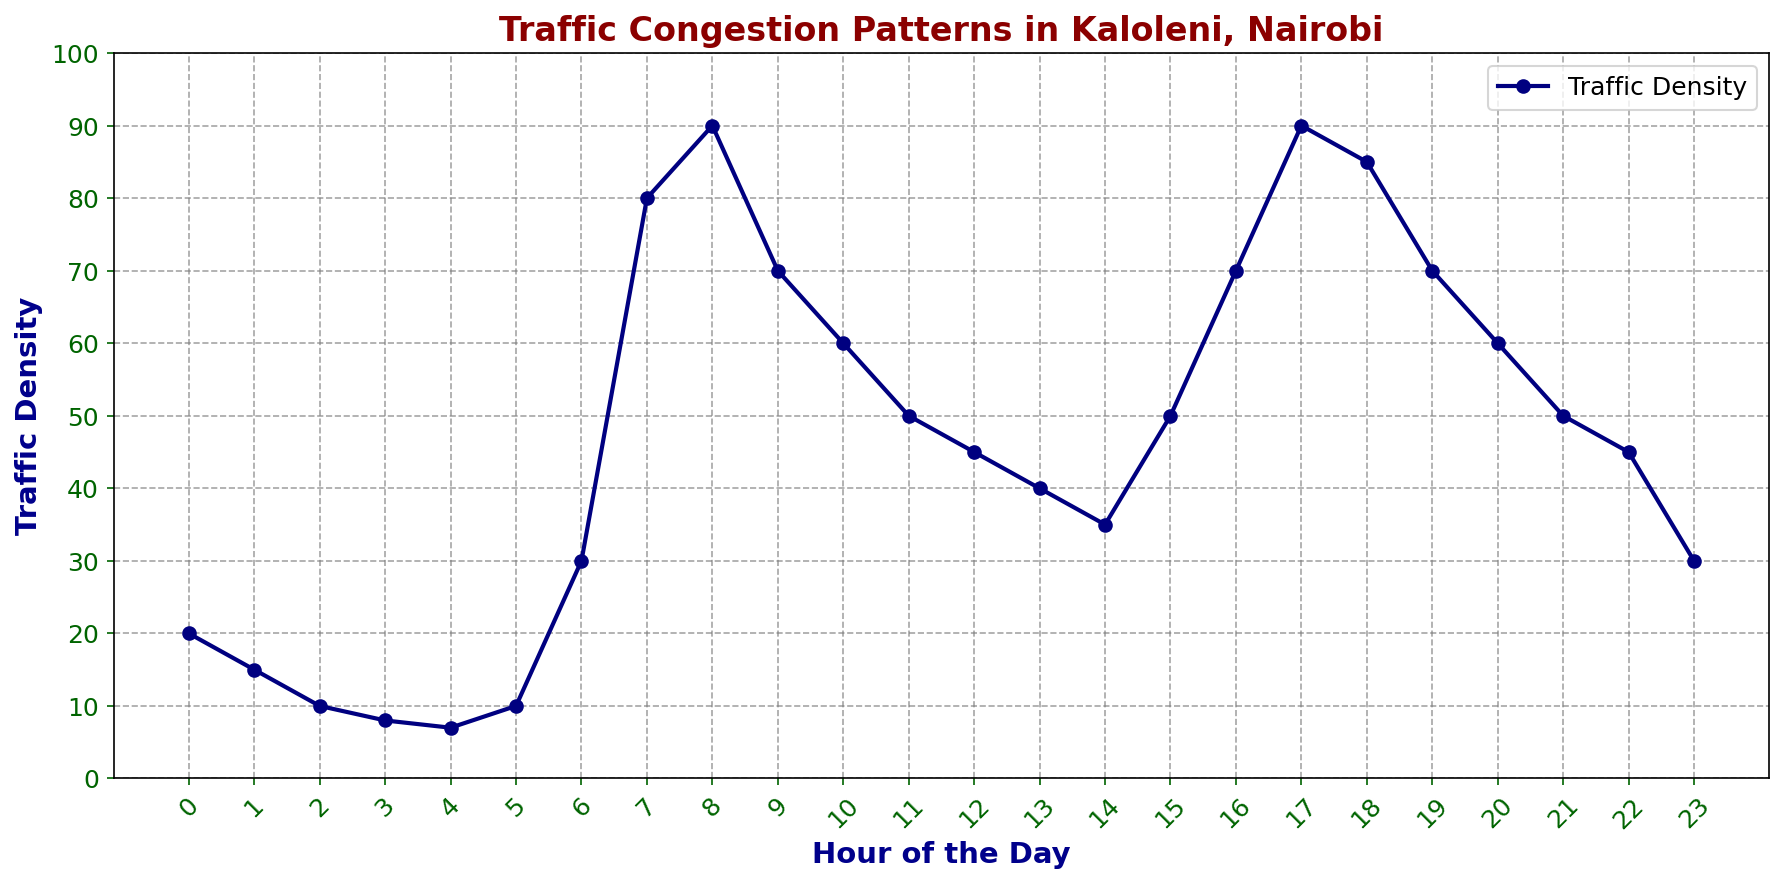What is the peak hour for traffic congestion in Kaloleni? First, locate the highest point in the plot representing traffic density. The peak occurs at 17:00 with a traffic density of 90.
Answer: 17:00 Which hour has the lowest traffic density? Identify the point in the plot with the minimum traffic density, which appears at hour 4 with a value of 7.
Answer: 4:00 How does traffic density at 6:00 compare to 15:00? Find the traffic density values at 6:00 and 15:00 on the plot. At 6:00, the density is 30, and at 15:00, it is 50. Therefore, 6:00 has less traffic than 15:00.
Answer: Less at 6:00 than at 15:00 What is the average traffic density between 8:00 and 10:00 inclusive? Sum the densities at 8:00 (90), 9:00 (70), and 10:00 (60) and divide by the number of hours (3): (90+70+60)/3 = 220/3 ≈ 73.33.
Answer: 73.33 Between which hours does traffic density increase the most rapidly? Observe the steepest incline in the plot, which occurs between 6:00 and 8:00, where traffic density climbs from 30 to 90.
Answer: 6:00 to 8:00 Which hour experiences a traffic density equal to 45? Find the points on the plot and identify 12:00 and 22:00, both having a traffic density of 45.
Answer: 12:00 and 22:00 How much does the traffic density decrease from its peak at 17:00 to 18:00? Calculate the difference in traffic density. At 17:00, it is 90, and at 18:00, it is 85. So, the decrease is 90 - 85 = 5.
Answer: 5 What two consecutive hours show the biggest drop in traffic density? Identify the steepest downward slope. Examining the plot shows the biggest drop between 8:00 (90) and 9:00 (70), a difference of 20.
Answer: 8:00 to 9:00 What is the total traffic density for the hours between 12:00 to 16:00 inclusive? Sum the densities from 12:00 to 16:00: 12:00 (45), 13:00 (40), 14:00 (35), 15:00 (50), and 16:00 (70). The total is 45 + 40 + 35 + 50 + 70 = 240.
Answer: 240 Which hours have traffic densities exactly 50? From the plot, see the traffic density is 50 at 11:00, 15:00, and 21:00.
Answer: 11:00, 15:00, and 21:00 